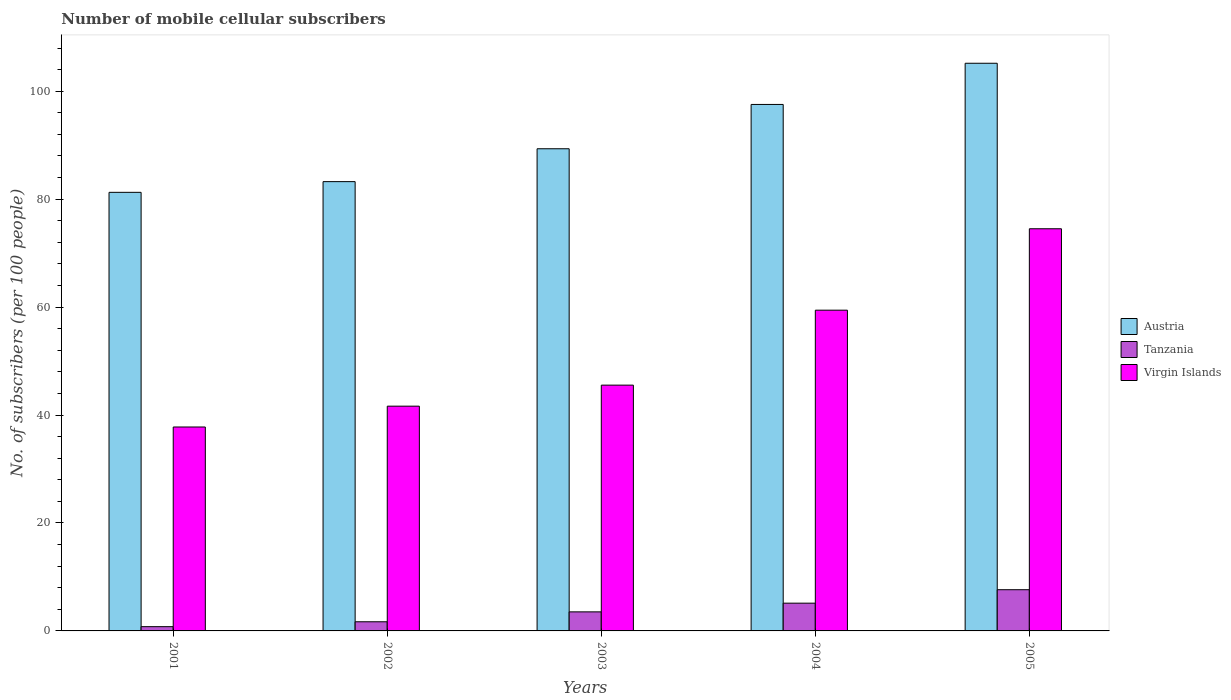How many bars are there on the 3rd tick from the right?
Your answer should be compact. 3. What is the number of mobile cellular subscribers in Tanzania in 2005?
Your response must be concise. 7.63. Across all years, what is the maximum number of mobile cellular subscribers in Austria?
Keep it short and to the point. 105.18. Across all years, what is the minimum number of mobile cellular subscribers in Virgin Islands?
Your response must be concise. 37.78. In which year was the number of mobile cellular subscribers in Austria maximum?
Your answer should be very brief. 2005. What is the total number of mobile cellular subscribers in Virgin Islands in the graph?
Your response must be concise. 258.9. What is the difference between the number of mobile cellular subscribers in Virgin Islands in 2002 and that in 2005?
Give a very brief answer. -32.87. What is the difference between the number of mobile cellular subscribers in Virgin Islands in 2005 and the number of mobile cellular subscribers in Austria in 2001?
Your answer should be very brief. -6.75. What is the average number of mobile cellular subscribers in Austria per year?
Your response must be concise. 91.31. In the year 2005, what is the difference between the number of mobile cellular subscribers in Virgin Islands and number of mobile cellular subscribers in Tanzania?
Your answer should be compact. 66.88. What is the ratio of the number of mobile cellular subscribers in Virgin Islands in 2002 to that in 2003?
Offer a terse response. 0.91. What is the difference between the highest and the second highest number of mobile cellular subscribers in Tanzania?
Your response must be concise. 2.49. What is the difference between the highest and the lowest number of mobile cellular subscribers in Virgin Islands?
Give a very brief answer. 36.73. What does the 3rd bar from the left in 2003 represents?
Your answer should be very brief. Virgin Islands. What does the 1st bar from the right in 2005 represents?
Keep it short and to the point. Virgin Islands. How many bars are there?
Your answer should be compact. 15. Does the graph contain any zero values?
Give a very brief answer. No. How many legend labels are there?
Your response must be concise. 3. How are the legend labels stacked?
Your answer should be compact. Vertical. What is the title of the graph?
Give a very brief answer. Number of mobile cellular subscribers. What is the label or title of the X-axis?
Offer a very short reply. Years. What is the label or title of the Y-axis?
Keep it short and to the point. No. of subscribers (per 100 people). What is the No. of subscribers (per 100 people) in Austria in 2001?
Your answer should be compact. 81.26. What is the No. of subscribers (per 100 people) in Tanzania in 2001?
Ensure brevity in your answer.  0.79. What is the No. of subscribers (per 100 people) of Virgin Islands in 2001?
Give a very brief answer. 37.78. What is the No. of subscribers (per 100 people) of Austria in 2002?
Your response must be concise. 83.24. What is the No. of subscribers (per 100 people) of Tanzania in 2002?
Offer a very short reply. 1.69. What is the No. of subscribers (per 100 people) of Virgin Islands in 2002?
Ensure brevity in your answer.  41.64. What is the No. of subscribers (per 100 people) in Austria in 2003?
Ensure brevity in your answer.  89.34. What is the No. of subscribers (per 100 people) of Tanzania in 2003?
Offer a terse response. 3.53. What is the No. of subscribers (per 100 people) in Virgin Islands in 2003?
Provide a short and direct response. 45.54. What is the No. of subscribers (per 100 people) of Austria in 2004?
Provide a short and direct response. 97.54. What is the No. of subscribers (per 100 people) in Tanzania in 2004?
Your answer should be compact. 5.14. What is the No. of subscribers (per 100 people) of Virgin Islands in 2004?
Your response must be concise. 59.43. What is the No. of subscribers (per 100 people) in Austria in 2005?
Make the answer very short. 105.18. What is the No. of subscribers (per 100 people) in Tanzania in 2005?
Provide a short and direct response. 7.63. What is the No. of subscribers (per 100 people) in Virgin Islands in 2005?
Ensure brevity in your answer.  74.51. Across all years, what is the maximum No. of subscribers (per 100 people) of Austria?
Make the answer very short. 105.18. Across all years, what is the maximum No. of subscribers (per 100 people) in Tanzania?
Your response must be concise. 7.63. Across all years, what is the maximum No. of subscribers (per 100 people) in Virgin Islands?
Offer a terse response. 74.51. Across all years, what is the minimum No. of subscribers (per 100 people) of Austria?
Your answer should be compact. 81.26. Across all years, what is the minimum No. of subscribers (per 100 people) in Tanzania?
Your answer should be compact. 0.79. Across all years, what is the minimum No. of subscribers (per 100 people) in Virgin Islands?
Your answer should be compact. 37.78. What is the total No. of subscribers (per 100 people) of Austria in the graph?
Provide a succinct answer. 456.56. What is the total No. of subscribers (per 100 people) in Tanzania in the graph?
Make the answer very short. 18.79. What is the total No. of subscribers (per 100 people) of Virgin Islands in the graph?
Your answer should be very brief. 258.9. What is the difference between the No. of subscribers (per 100 people) of Austria in 2001 and that in 2002?
Provide a short and direct response. -1.98. What is the difference between the No. of subscribers (per 100 people) in Tanzania in 2001 and that in 2002?
Your answer should be compact. -0.91. What is the difference between the No. of subscribers (per 100 people) of Virgin Islands in 2001 and that in 2002?
Provide a short and direct response. -3.86. What is the difference between the No. of subscribers (per 100 people) of Austria in 2001 and that in 2003?
Offer a terse response. -8.08. What is the difference between the No. of subscribers (per 100 people) of Tanzania in 2001 and that in 2003?
Give a very brief answer. -2.74. What is the difference between the No. of subscribers (per 100 people) in Virgin Islands in 2001 and that in 2003?
Offer a terse response. -7.75. What is the difference between the No. of subscribers (per 100 people) in Austria in 2001 and that in 2004?
Ensure brevity in your answer.  -16.28. What is the difference between the No. of subscribers (per 100 people) in Tanzania in 2001 and that in 2004?
Your answer should be compact. -4.35. What is the difference between the No. of subscribers (per 100 people) in Virgin Islands in 2001 and that in 2004?
Your answer should be very brief. -21.64. What is the difference between the No. of subscribers (per 100 people) in Austria in 2001 and that in 2005?
Keep it short and to the point. -23.92. What is the difference between the No. of subscribers (per 100 people) of Tanzania in 2001 and that in 2005?
Keep it short and to the point. -6.84. What is the difference between the No. of subscribers (per 100 people) in Virgin Islands in 2001 and that in 2005?
Your answer should be very brief. -36.73. What is the difference between the No. of subscribers (per 100 people) of Austria in 2002 and that in 2003?
Offer a terse response. -6.09. What is the difference between the No. of subscribers (per 100 people) of Tanzania in 2002 and that in 2003?
Offer a very short reply. -1.84. What is the difference between the No. of subscribers (per 100 people) of Virgin Islands in 2002 and that in 2003?
Provide a short and direct response. -3.9. What is the difference between the No. of subscribers (per 100 people) in Austria in 2002 and that in 2004?
Provide a short and direct response. -14.3. What is the difference between the No. of subscribers (per 100 people) in Tanzania in 2002 and that in 2004?
Your answer should be compact. -3.45. What is the difference between the No. of subscribers (per 100 people) in Virgin Islands in 2002 and that in 2004?
Provide a short and direct response. -17.78. What is the difference between the No. of subscribers (per 100 people) in Austria in 2002 and that in 2005?
Provide a succinct answer. -21.93. What is the difference between the No. of subscribers (per 100 people) of Tanzania in 2002 and that in 2005?
Offer a very short reply. -5.94. What is the difference between the No. of subscribers (per 100 people) in Virgin Islands in 2002 and that in 2005?
Provide a succinct answer. -32.87. What is the difference between the No. of subscribers (per 100 people) of Austria in 2003 and that in 2004?
Make the answer very short. -8.21. What is the difference between the No. of subscribers (per 100 people) in Tanzania in 2003 and that in 2004?
Your response must be concise. -1.61. What is the difference between the No. of subscribers (per 100 people) of Virgin Islands in 2003 and that in 2004?
Your answer should be compact. -13.89. What is the difference between the No. of subscribers (per 100 people) of Austria in 2003 and that in 2005?
Ensure brevity in your answer.  -15.84. What is the difference between the No. of subscribers (per 100 people) of Tanzania in 2003 and that in 2005?
Make the answer very short. -4.1. What is the difference between the No. of subscribers (per 100 people) of Virgin Islands in 2003 and that in 2005?
Ensure brevity in your answer.  -28.97. What is the difference between the No. of subscribers (per 100 people) in Austria in 2004 and that in 2005?
Your response must be concise. -7.63. What is the difference between the No. of subscribers (per 100 people) of Tanzania in 2004 and that in 2005?
Keep it short and to the point. -2.49. What is the difference between the No. of subscribers (per 100 people) of Virgin Islands in 2004 and that in 2005?
Offer a terse response. -15.09. What is the difference between the No. of subscribers (per 100 people) in Austria in 2001 and the No. of subscribers (per 100 people) in Tanzania in 2002?
Provide a short and direct response. 79.57. What is the difference between the No. of subscribers (per 100 people) in Austria in 2001 and the No. of subscribers (per 100 people) in Virgin Islands in 2002?
Offer a very short reply. 39.62. What is the difference between the No. of subscribers (per 100 people) of Tanzania in 2001 and the No. of subscribers (per 100 people) of Virgin Islands in 2002?
Make the answer very short. -40.85. What is the difference between the No. of subscribers (per 100 people) of Austria in 2001 and the No. of subscribers (per 100 people) of Tanzania in 2003?
Your response must be concise. 77.73. What is the difference between the No. of subscribers (per 100 people) in Austria in 2001 and the No. of subscribers (per 100 people) in Virgin Islands in 2003?
Make the answer very short. 35.72. What is the difference between the No. of subscribers (per 100 people) of Tanzania in 2001 and the No. of subscribers (per 100 people) of Virgin Islands in 2003?
Provide a short and direct response. -44.75. What is the difference between the No. of subscribers (per 100 people) in Austria in 2001 and the No. of subscribers (per 100 people) in Tanzania in 2004?
Give a very brief answer. 76.12. What is the difference between the No. of subscribers (per 100 people) in Austria in 2001 and the No. of subscribers (per 100 people) in Virgin Islands in 2004?
Keep it short and to the point. 21.83. What is the difference between the No. of subscribers (per 100 people) in Tanzania in 2001 and the No. of subscribers (per 100 people) in Virgin Islands in 2004?
Your answer should be compact. -58.64. What is the difference between the No. of subscribers (per 100 people) of Austria in 2001 and the No. of subscribers (per 100 people) of Tanzania in 2005?
Offer a very short reply. 73.63. What is the difference between the No. of subscribers (per 100 people) in Austria in 2001 and the No. of subscribers (per 100 people) in Virgin Islands in 2005?
Your answer should be compact. 6.75. What is the difference between the No. of subscribers (per 100 people) of Tanzania in 2001 and the No. of subscribers (per 100 people) of Virgin Islands in 2005?
Make the answer very short. -73.72. What is the difference between the No. of subscribers (per 100 people) in Austria in 2002 and the No. of subscribers (per 100 people) in Tanzania in 2003?
Give a very brief answer. 79.71. What is the difference between the No. of subscribers (per 100 people) of Austria in 2002 and the No. of subscribers (per 100 people) of Virgin Islands in 2003?
Ensure brevity in your answer.  37.71. What is the difference between the No. of subscribers (per 100 people) in Tanzania in 2002 and the No. of subscribers (per 100 people) in Virgin Islands in 2003?
Your answer should be very brief. -43.84. What is the difference between the No. of subscribers (per 100 people) of Austria in 2002 and the No. of subscribers (per 100 people) of Tanzania in 2004?
Offer a very short reply. 78.1. What is the difference between the No. of subscribers (per 100 people) in Austria in 2002 and the No. of subscribers (per 100 people) in Virgin Islands in 2004?
Your answer should be compact. 23.82. What is the difference between the No. of subscribers (per 100 people) in Tanzania in 2002 and the No. of subscribers (per 100 people) in Virgin Islands in 2004?
Offer a terse response. -57.73. What is the difference between the No. of subscribers (per 100 people) in Austria in 2002 and the No. of subscribers (per 100 people) in Tanzania in 2005?
Provide a succinct answer. 75.61. What is the difference between the No. of subscribers (per 100 people) of Austria in 2002 and the No. of subscribers (per 100 people) of Virgin Islands in 2005?
Your answer should be very brief. 8.73. What is the difference between the No. of subscribers (per 100 people) in Tanzania in 2002 and the No. of subscribers (per 100 people) in Virgin Islands in 2005?
Provide a succinct answer. -72.82. What is the difference between the No. of subscribers (per 100 people) of Austria in 2003 and the No. of subscribers (per 100 people) of Tanzania in 2004?
Provide a succinct answer. 84.19. What is the difference between the No. of subscribers (per 100 people) of Austria in 2003 and the No. of subscribers (per 100 people) of Virgin Islands in 2004?
Keep it short and to the point. 29.91. What is the difference between the No. of subscribers (per 100 people) of Tanzania in 2003 and the No. of subscribers (per 100 people) of Virgin Islands in 2004?
Provide a short and direct response. -55.89. What is the difference between the No. of subscribers (per 100 people) in Austria in 2003 and the No. of subscribers (per 100 people) in Tanzania in 2005?
Keep it short and to the point. 81.7. What is the difference between the No. of subscribers (per 100 people) in Austria in 2003 and the No. of subscribers (per 100 people) in Virgin Islands in 2005?
Make the answer very short. 14.82. What is the difference between the No. of subscribers (per 100 people) in Tanzania in 2003 and the No. of subscribers (per 100 people) in Virgin Islands in 2005?
Offer a terse response. -70.98. What is the difference between the No. of subscribers (per 100 people) of Austria in 2004 and the No. of subscribers (per 100 people) of Tanzania in 2005?
Offer a very short reply. 89.91. What is the difference between the No. of subscribers (per 100 people) in Austria in 2004 and the No. of subscribers (per 100 people) in Virgin Islands in 2005?
Your answer should be very brief. 23.03. What is the difference between the No. of subscribers (per 100 people) of Tanzania in 2004 and the No. of subscribers (per 100 people) of Virgin Islands in 2005?
Provide a short and direct response. -69.37. What is the average No. of subscribers (per 100 people) of Austria per year?
Offer a terse response. 91.31. What is the average No. of subscribers (per 100 people) in Tanzania per year?
Your response must be concise. 3.76. What is the average No. of subscribers (per 100 people) in Virgin Islands per year?
Your response must be concise. 51.78. In the year 2001, what is the difference between the No. of subscribers (per 100 people) in Austria and No. of subscribers (per 100 people) in Tanzania?
Provide a short and direct response. 80.47. In the year 2001, what is the difference between the No. of subscribers (per 100 people) of Austria and No. of subscribers (per 100 people) of Virgin Islands?
Provide a succinct answer. 43.48. In the year 2001, what is the difference between the No. of subscribers (per 100 people) of Tanzania and No. of subscribers (per 100 people) of Virgin Islands?
Make the answer very short. -36.99. In the year 2002, what is the difference between the No. of subscribers (per 100 people) in Austria and No. of subscribers (per 100 people) in Tanzania?
Ensure brevity in your answer.  81.55. In the year 2002, what is the difference between the No. of subscribers (per 100 people) in Austria and No. of subscribers (per 100 people) in Virgin Islands?
Your answer should be very brief. 41.6. In the year 2002, what is the difference between the No. of subscribers (per 100 people) in Tanzania and No. of subscribers (per 100 people) in Virgin Islands?
Make the answer very short. -39.95. In the year 2003, what is the difference between the No. of subscribers (per 100 people) in Austria and No. of subscribers (per 100 people) in Tanzania?
Offer a terse response. 85.8. In the year 2003, what is the difference between the No. of subscribers (per 100 people) of Austria and No. of subscribers (per 100 people) of Virgin Islands?
Your answer should be very brief. 43.8. In the year 2003, what is the difference between the No. of subscribers (per 100 people) of Tanzania and No. of subscribers (per 100 people) of Virgin Islands?
Make the answer very short. -42.01. In the year 2004, what is the difference between the No. of subscribers (per 100 people) in Austria and No. of subscribers (per 100 people) in Tanzania?
Give a very brief answer. 92.4. In the year 2004, what is the difference between the No. of subscribers (per 100 people) of Austria and No. of subscribers (per 100 people) of Virgin Islands?
Make the answer very short. 38.12. In the year 2004, what is the difference between the No. of subscribers (per 100 people) in Tanzania and No. of subscribers (per 100 people) in Virgin Islands?
Keep it short and to the point. -54.28. In the year 2005, what is the difference between the No. of subscribers (per 100 people) in Austria and No. of subscribers (per 100 people) in Tanzania?
Make the answer very short. 97.54. In the year 2005, what is the difference between the No. of subscribers (per 100 people) in Austria and No. of subscribers (per 100 people) in Virgin Islands?
Provide a succinct answer. 30.66. In the year 2005, what is the difference between the No. of subscribers (per 100 people) in Tanzania and No. of subscribers (per 100 people) in Virgin Islands?
Ensure brevity in your answer.  -66.88. What is the ratio of the No. of subscribers (per 100 people) of Austria in 2001 to that in 2002?
Your answer should be compact. 0.98. What is the ratio of the No. of subscribers (per 100 people) in Tanzania in 2001 to that in 2002?
Give a very brief answer. 0.47. What is the ratio of the No. of subscribers (per 100 people) in Virgin Islands in 2001 to that in 2002?
Your answer should be compact. 0.91. What is the ratio of the No. of subscribers (per 100 people) of Austria in 2001 to that in 2003?
Offer a terse response. 0.91. What is the ratio of the No. of subscribers (per 100 people) in Tanzania in 2001 to that in 2003?
Give a very brief answer. 0.22. What is the ratio of the No. of subscribers (per 100 people) in Virgin Islands in 2001 to that in 2003?
Your response must be concise. 0.83. What is the ratio of the No. of subscribers (per 100 people) in Austria in 2001 to that in 2004?
Your answer should be very brief. 0.83. What is the ratio of the No. of subscribers (per 100 people) of Tanzania in 2001 to that in 2004?
Offer a terse response. 0.15. What is the ratio of the No. of subscribers (per 100 people) of Virgin Islands in 2001 to that in 2004?
Provide a succinct answer. 0.64. What is the ratio of the No. of subscribers (per 100 people) of Austria in 2001 to that in 2005?
Give a very brief answer. 0.77. What is the ratio of the No. of subscribers (per 100 people) of Tanzania in 2001 to that in 2005?
Provide a succinct answer. 0.1. What is the ratio of the No. of subscribers (per 100 people) in Virgin Islands in 2001 to that in 2005?
Provide a short and direct response. 0.51. What is the ratio of the No. of subscribers (per 100 people) of Austria in 2002 to that in 2003?
Offer a very short reply. 0.93. What is the ratio of the No. of subscribers (per 100 people) of Tanzania in 2002 to that in 2003?
Keep it short and to the point. 0.48. What is the ratio of the No. of subscribers (per 100 people) in Virgin Islands in 2002 to that in 2003?
Offer a terse response. 0.91. What is the ratio of the No. of subscribers (per 100 people) of Austria in 2002 to that in 2004?
Your response must be concise. 0.85. What is the ratio of the No. of subscribers (per 100 people) in Tanzania in 2002 to that in 2004?
Ensure brevity in your answer.  0.33. What is the ratio of the No. of subscribers (per 100 people) of Virgin Islands in 2002 to that in 2004?
Make the answer very short. 0.7. What is the ratio of the No. of subscribers (per 100 people) in Austria in 2002 to that in 2005?
Offer a terse response. 0.79. What is the ratio of the No. of subscribers (per 100 people) in Tanzania in 2002 to that in 2005?
Your answer should be compact. 0.22. What is the ratio of the No. of subscribers (per 100 people) of Virgin Islands in 2002 to that in 2005?
Offer a very short reply. 0.56. What is the ratio of the No. of subscribers (per 100 people) of Austria in 2003 to that in 2004?
Provide a short and direct response. 0.92. What is the ratio of the No. of subscribers (per 100 people) of Tanzania in 2003 to that in 2004?
Give a very brief answer. 0.69. What is the ratio of the No. of subscribers (per 100 people) of Virgin Islands in 2003 to that in 2004?
Provide a short and direct response. 0.77. What is the ratio of the No. of subscribers (per 100 people) of Austria in 2003 to that in 2005?
Offer a very short reply. 0.85. What is the ratio of the No. of subscribers (per 100 people) in Tanzania in 2003 to that in 2005?
Offer a very short reply. 0.46. What is the ratio of the No. of subscribers (per 100 people) in Virgin Islands in 2003 to that in 2005?
Offer a terse response. 0.61. What is the ratio of the No. of subscribers (per 100 people) of Austria in 2004 to that in 2005?
Offer a terse response. 0.93. What is the ratio of the No. of subscribers (per 100 people) of Tanzania in 2004 to that in 2005?
Your answer should be compact. 0.67. What is the ratio of the No. of subscribers (per 100 people) in Virgin Islands in 2004 to that in 2005?
Your answer should be very brief. 0.8. What is the difference between the highest and the second highest No. of subscribers (per 100 people) in Austria?
Offer a terse response. 7.63. What is the difference between the highest and the second highest No. of subscribers (per 100 people) of Tanzania?
Provide a succinct answer. 2.49. What is the difference between the highest and the second highest No. of subscribers (per 100 people) of Virgin Islands?
Your answer should be compact. 15.09. What is the difference between the highest and the lowest No. of subscribers (per 100 people) of Austria?
Give a very brief answer. 23.92. What is the difference between the highest and the lowest No. of subscribers (per 100 people) in Tanzania?
Offer a very short reply. 6.84. What is the difference between the highest and the lowest No. of subscribers (per 100 people) of Virgin Islands?
Make the answer very short. 36.73. 